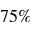<formula> <loc_0><loc_0><loc_500><loc_500>7 5 \%</formula> 